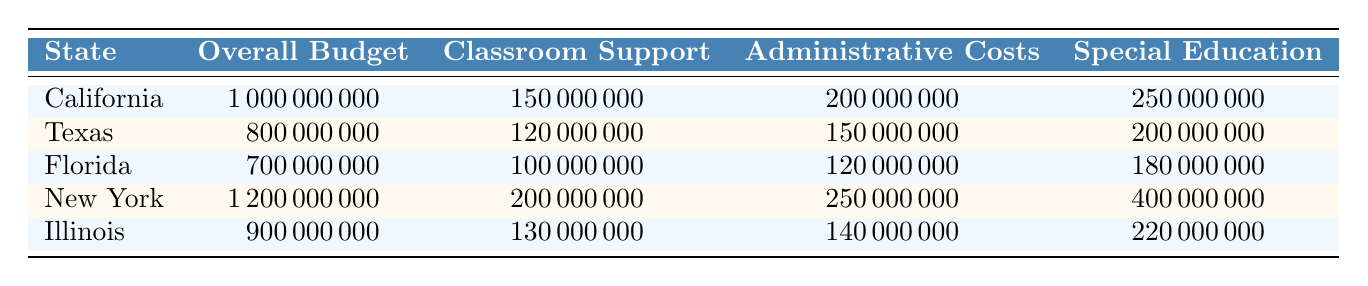What state has the highest overall budget? By examining the "Overall Budget" column, New York has the highest budget listed at 1,200,000,000.
Answer: New York What is the total classroom support budget across all states? The classroom support amounts are California (150,000,000), Texas (120,000,000), Florida (100,000,000), New York (200,000,000), and Illinois (130,000,000). Adding these gives 150 + 120 + 100 + 200 + 130 = 700,000,000.
Answer: 700,000,000 Which state allocates the least amount of money for special education? Comparing the special education budgets, Florida has the smallest allocation of 180,000,000.
Answer: Florida Is Texas spending more on administrative costs than Illinois? Texas's administrative costs are 150,000,000, while Illinois's are 140,000,000. Since 150,000,000 is greater than 140,000,000, the answer is yes.
Answer: Yes What is the difference in the overall budget between New York and Florida? New York's overall budget is 1,200,000,000 and Florida's is 700,000,000. The difference is 1,200,000,000 - 700,000,000 = 500,000,000.
Answer: 500,000,000 What percentage of California's overall budget is dedicated to special education? To find the percentage, divide California's special education budget (250,000,000) by its overall budget (1,000,000,000) and multiply by 100. Thus, (250,000,000 / 1,000,000,000) * 100 = 25%.
Answer: 25% Which state's budget allocation for administrative costs is the closest to the average of all states? First, we calculate the average of administrative costs: (200,000,000 + 150,000,000 + 120,000,000 + 250,000,000 + 140,000,000) / 5 = 172,000,000. The state closest to this amount is Texas with 150,000,000.
Answer: Texas If we combine the amounts for classroom support and special education across all states, which state has the highest combined total? For each state, calculate the sum of classroom support and special education: California (150M + 250M = 400M), Texas (120M + 200M = 320M), Florida (100M + 180M = 280M), New York (200M + 400M = 600M), Illinois (130M + 220M = 350M). New York has the highest at 600M.
Answer: New York Does any state allocate more than 50 million for parent involvement programs? Checking the parent involvement programs budget: California (50M), Texas (30M), Florida (5M), New York (10M), Illinois (20M). Only California meets this criterion.
Answer: Yes What is the total budget allocated for infrastructure development across all states? The infrastructure development budgets are: California (300,000,000), Texas (250,000,000), Florida (250,000,000), New York (300,000,000), Illinois (300,000,000). Totaling these gives 300 + 250 + 250 + 300 + 300 = 1,400,000,000.
Answer: 1,400,000,000 